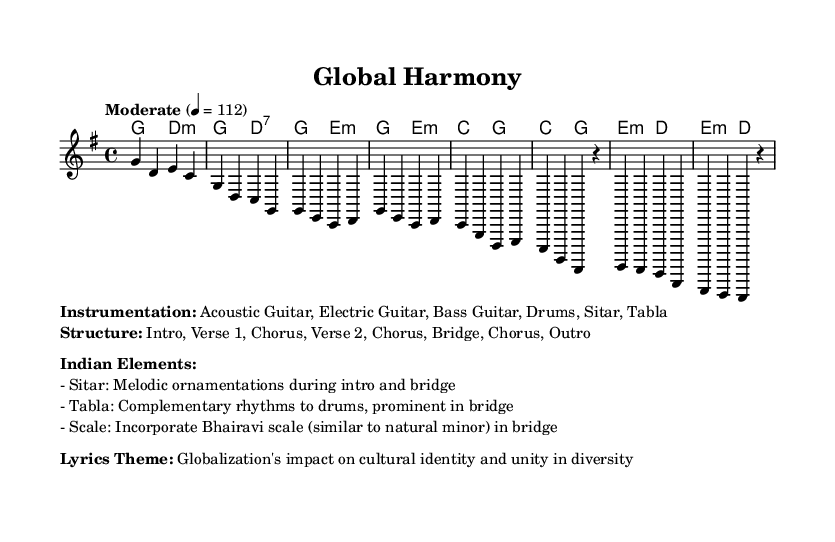What is the key signature of this music? The key signature is G major, which has one sharp (F#). This is indicated at the beginning of the sheet music.
Answer: G major What is the time signature of the piece? The time signature is 4/4, which means there are four beats in each measure and the quarter note receives one beat. This is specified in the beginning of the score.
Answer: 4/4 What is the tempo marking for this music? The tempo marking is "Moderate" at a speed of 112 beats per minute. This is noted in the tempo instruction above the measure.
Answer: Moderate 4 = 112 What instruments are used in this composition? The instrumentation includes Acoustic Guitar, Electric Guitar, Bass Guitar, Drums, Sitar, and Tabla. This is detailed in the markup section that lists the instrumentation.
Answer: Acoustic Guitar, Electric Guitar, Bass Guitar, Drums, Sitar, Tabla How many main sections are in the song structure? The song structure consists of 7 main sections: Intro, Verse 1, Chorus, Verse 2, Chorus, Bridge, and Outro. The structure is outlined in the markup portion of the sheet music.
Answer: 7 What scale is incorporated in the bridge section? The bridge section incorporates the Bhairavi scale, which is similar to the natural minor scale. This element is mentioned specifically in the Indian Elements section of the markup.
Answer: Bhairavi scale What thematic issue does the song address? The lyrics theme addresses globalization's impact on cultural identity and unity in diversity. This thematic issue is noted in the markup section under Lyrics Theme.
Answer: Globalization's impact on cultural identity and unity in diversity 